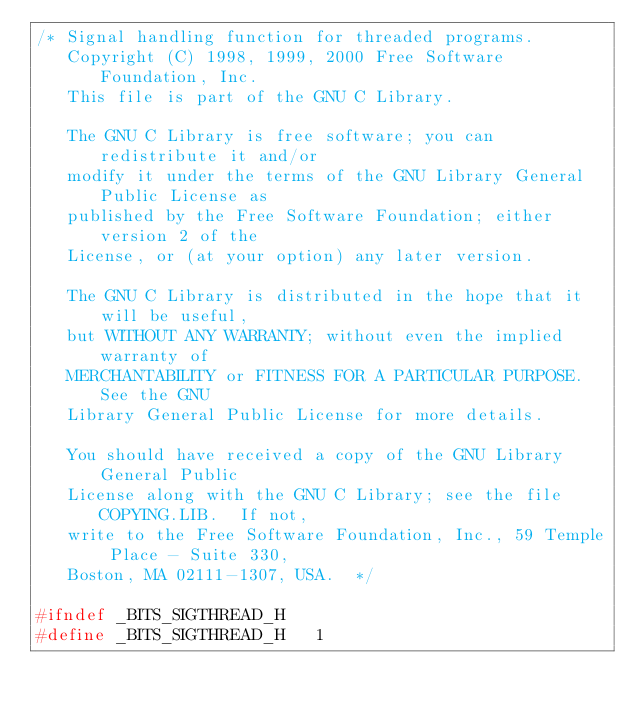<code> <loc_0><loc_0><loc_500><loc_500><_C_>/* Signal handling function for threaded programs.
   Copyright (C) 1998, 1999, 2000 Free Software Foundation, Inc.
   This file is part of the GNU C Library.

   The GNU C Library is free software; you can redistribute it and/or
   modify it under the terms of the GNU Library General Public License as
   published by the Free Software Foundation; either version 2 of the
   License, or (at your option) any later version.

   The GNU C Library is distributed in the hope that it will be useful,
   but WITHOUT ANY WARRANTY; without even the implied warranty of
   MERCHANTABILITY or FITNESS FOR A PARTICULAR PURPOSE.  See the GNU
   Library General Public License for more details.

   You should have received a copy of the GNU Library General Public
   License along with the GNU C Library; see the file COPYING.LIB.  If not,
   write to the Free Software Foundation, Inc., 59 Temple Place - Suite 330,
   Boston, MA 02111-1307, USA.  */

#ifndef _BITS_SIGTHREAD_H
#define _BITS_SIGTHREAD_H	1
</code> 